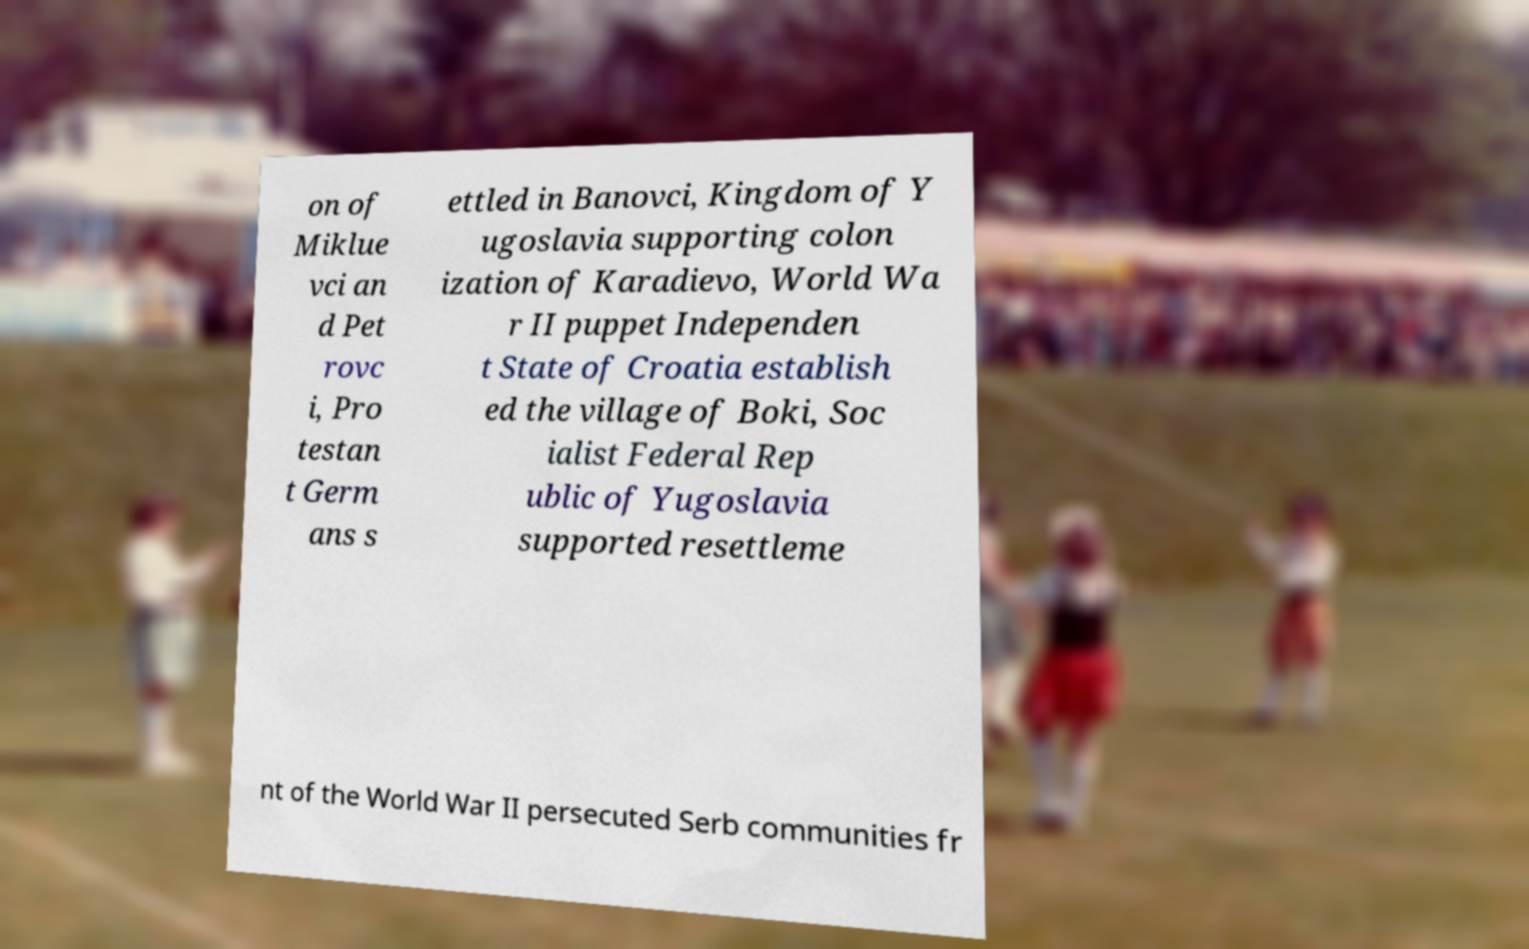Please read and relay the text visible in this image. What does it say? on of Miklue vci an d Pet rovc i, Pro testan t Germ ans s ettled in Banovci, Kingdom of Y ugoslavia supporting colon ization of Karadievo, World Wa r II puppet Independen t State of Croatia establish ed the village of Boki, Soc ialist Federal Rep ublic of Yugoslavia supported resettleme nt of the World War II persecuted Serb communities fr 